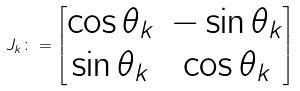<formula> <loc_0><loc_0><loc_500><loc_500>J _ { k } \colon = \begin{bmatrix} \cos \theta _ { k } & - \sin \theta _ { k } \\ \sin \theta _ { k } & \cos \theta _ { k } \end{bmatrix}</formula> 